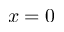<formula> <loc_0><loc_0><loc_500><loc_500>x = 0</formula> 